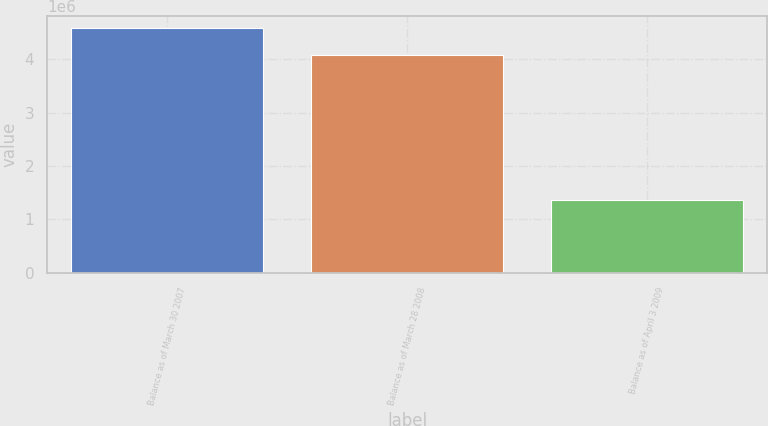Convert chart. <chart><loc_0><loc_0><loc_500><loc_500><bar_chart><fcel>Balance as of March 30 2007<fcel>Balance as of March 28 2008<fcel>Balance as of April 3 2009<nl><fcel>4.58207e+06<fcel>4.08072e+06<fcel>1.35453e+06<nl></chart> 